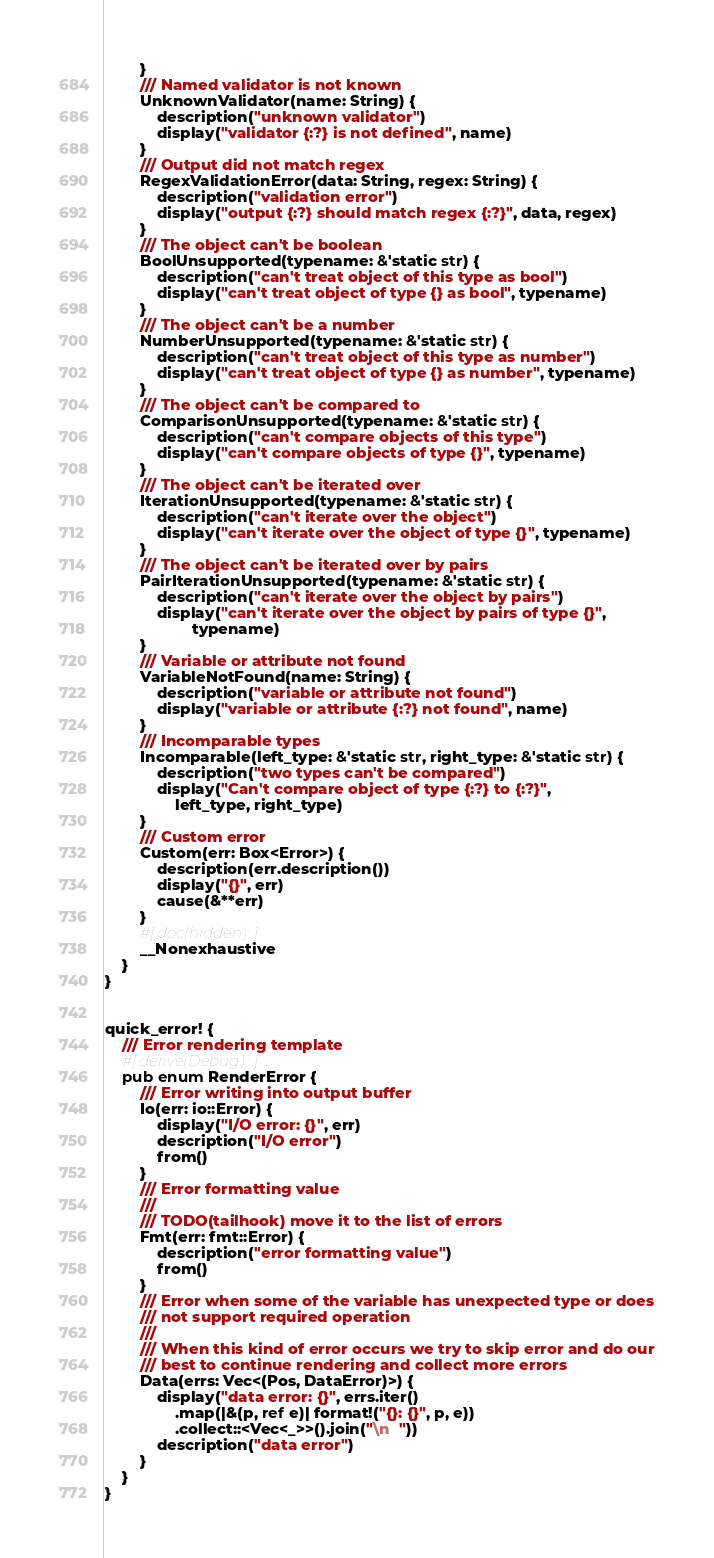Convert code to text. <code><loc_0><loc_0><loc_500><loc_500><_Rust_>        }
        /// Named validator is not known
        UnknownValidator(name: String) {
            description("unknown validator")
            display("validator {:?} is not defined", name)
        }
        /// Output did not match regex
        RegexValidationError(data: String, regex: String) {
            description("validation error")
            display("output {:?} should match regex {:?}", data, regex)
        }
        /// The object can't be boolean
        BoolUnsupported(typename: &'static str) {
            description("can't treat object of this type as bool")
            display("can't treat object of type {} as bool", typename)
        }
        /// The object can't be a number
        NumberUnsupported(typename: &'static str) {
            description("can't treat object of this type as number")
            display("can't treat object of type {} as number", typename)
        }
        /// The object can't be compared to
        ComparisonUnsupported(typename: &'static str) {
            description("can't compare objects of this type")
            display("can't compare objects of type {}", typename)
        }
        /// The object can't be iterated over
        IterationUnsupported(typename: &'static str) {
            description("can't iterate over the object")
            display("can't iterate over the object of type {}", typename)
        }
        /// The object can't be iterated over by pairs
        PairIterationUnsupported(typename: &'static str) {
            description("can't iterate over the object by pairs")
            display("can't iterate over the object by pairs of type {}",
                    typename)
        }
        /// Variable or attribute not found
        VariableNotFound(name: String) {
            description("variable or attribute not found")
            display("variable or attribute {:?} not found", name)
        }
        /// Incomparable types
        Incomparable(left_type: &'static str, right_type: &'static str) {
            description("two types can't be compared")
            display("Can't compare object of type {:?} to {:?}",
                left_type, right_type)
        }
        /// Custom error
        Custom(err: Box<Error>) {
            description(err.description())
            display("{}", err)
            cause(&**err)
        }
        #[doc(hidden)]
        __Nonexhaustive
    }
}


quick_error! {
    /// Error rendering template
    #[derive(Debug)]
    pub enum RenderError {
        /// Error writing into output buffer
        Io(err: io::Error) {
            display("I/O error: {}", err)
            description("I/O error")
            from()
        }
        /// Error formatting value
        ///
        /// TODO(tailhook) move it to the list of errors
        Fmt(err: fmt::Error) {
            description("error formatting value")
            from()
        }
        /// Error when some of the variable has unexpected type or does
        /// not support required operation
        ///
        /// When this kind of error occurs we try to skip error and do our
        /// best to continue rendering and collect more errors
        Data(errs: Vec<(Pos, DataError)>) {
            display("data error: {}", errs.iter()
                .map(|&(p, ref e)| format!("{}: {}", p, e))
                .collect::<Vec<_>>().join("\n  "))
            description("data error")
        }
    }
}
</code> 